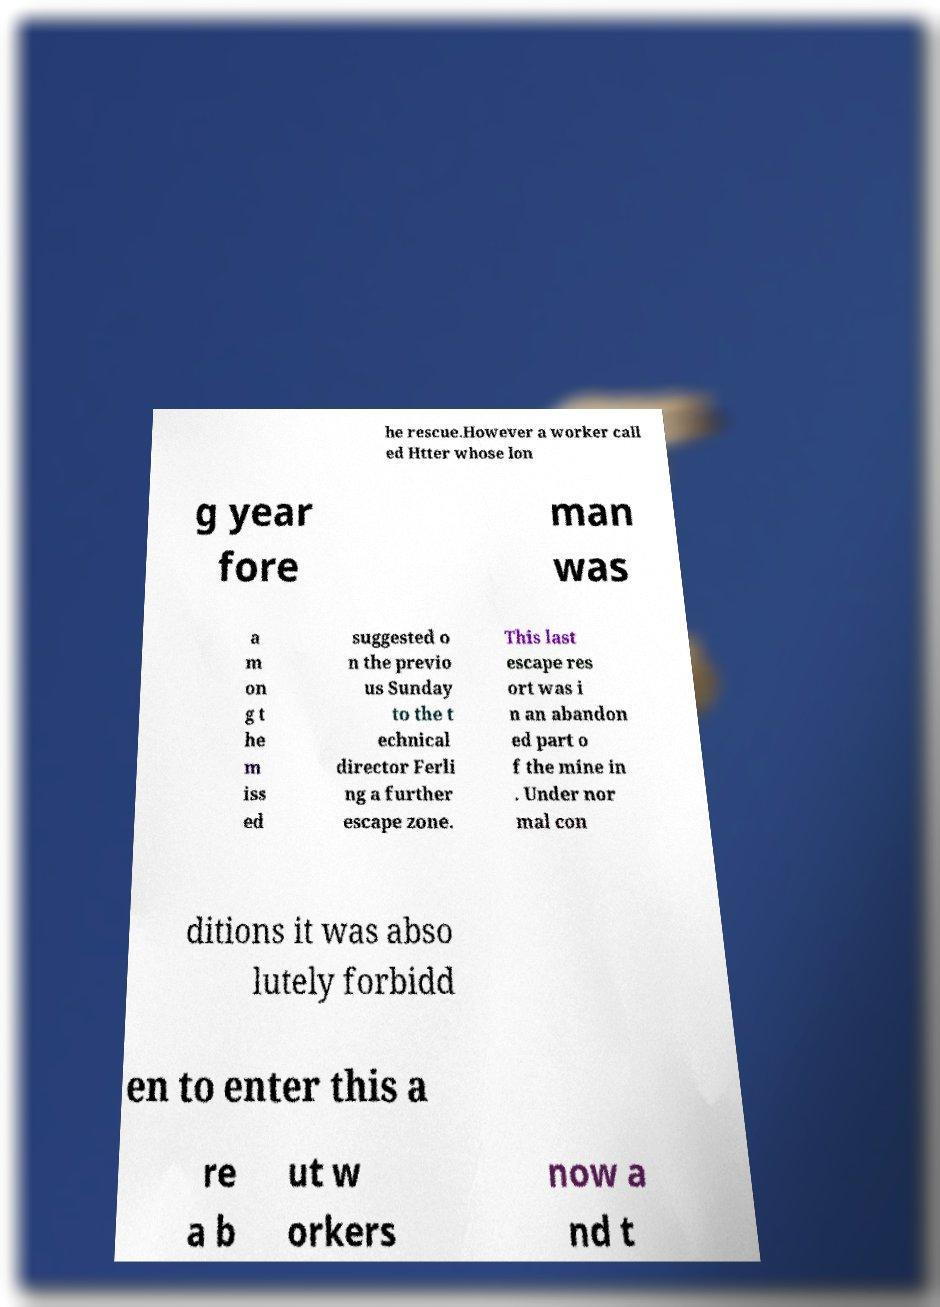There's text embedded in this image that I need extracted. Can you transcribe it verbatim? he rescue.However a worker call ed Htter whose lon g year fore man was a m on g t he m iss ed suggested o n the previo us Sunday to the t echnical director Ferli ng a further escape zone. This last escape res ort was i n an abandon ed part o f the mine in . Under nor mal con ditions it was abso lutely forbidd en to enter this a re a b ut w orkers now a nd t 